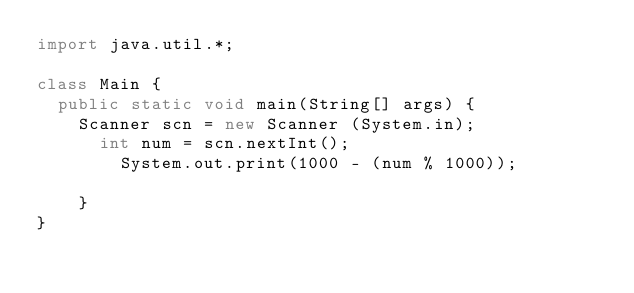Convert code to text. <code><loc_0><loc_0><loc_500><loc_500><_Java_>import java.util.*;
 
class Main {
	public static void main(String[] args) {
		Scanner scn = new Scanner (System.in);
     	int num = scn.nextInt();
      	System.out.print(1000 - (num % 1000));
      	
    }
}</code> 